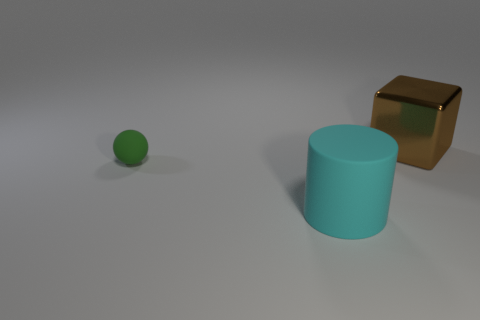Add 3 big brown things. How many objects exist? 6 Subtract all spheres. How many objects are left? 2 Subtract all red cylinders. Subtract all green blocks. How many cylinders are left? 1 Subtract all yellow blocks. How many yellow cylinders are left? 0 Subtract all blocks. Subtract all blue metallic cylinders. How many objects are left? 2 Add 2 tiny matte balls. How many tiny matte balls are left? 3 Add 3 tiny gray metallic things. How many tiny gray metallic things exist? 3 Subtract 1 cyan cylinders. How many objects are left? 2 